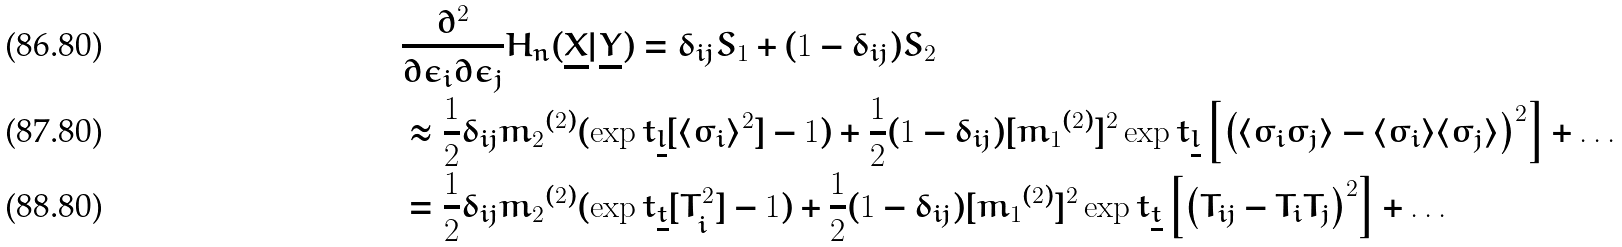Convert formula to latex. <formula><loc_0><loc_0><loc_500><loc_500>& \frac { \partial ^ { 2 } } { \partial \epsilon _ { i } \partial \epsilon _ { j } } H _ { n } ( \underline { X } | \underline { Y } ) = \delta _ { i j } S _ { 1 } + ( 1 - \delta _ { i j } ) S _ { 2 } \\ & \approx \frac { 1 } { 2 } \delta _ { i j } { m _ { 2 } } ^ { ( 2 ) } ( \exp t _ { \underline { l } } [ \langle \sigma _ { i } \rangle ^ { 2 } ] - 1 ) + \frac { 1 } { 2 } ( 1 - \delta _ { i j } ) [ { m _ { 1 } } ^ { ( 2 ) } ] ^ { 2 } \exp t _ { \underline { l } } \left [ \left ( \langle \sigma _ { i } \sigma _ { j } \rangle - \langle \sigma _ { i } \rangle \langle \sigma _ { j } \rangle \right ) ^ { 2 } \right ] + \dots \\ & = \frac { 1 } { 2 } \delta _ { i j } { m _ { 2 } } ^ { ( 2 ) } ( \exp t _ { \underline { t } } [ T _ { i } ^ { 2 } ] - 1 ) + \frac { 1 } { 2 } ( 1 - \delta _ { i j } ) [ { m _ { 1 } } ^ { ( 2 ) } ] ^ { 2 } \exp t _ { \underline { t } } \left [ \left ( T _ { i j } - T _ { i } T _ { j } \right ) ^ { 2 } \right ] + \dots</formula> 